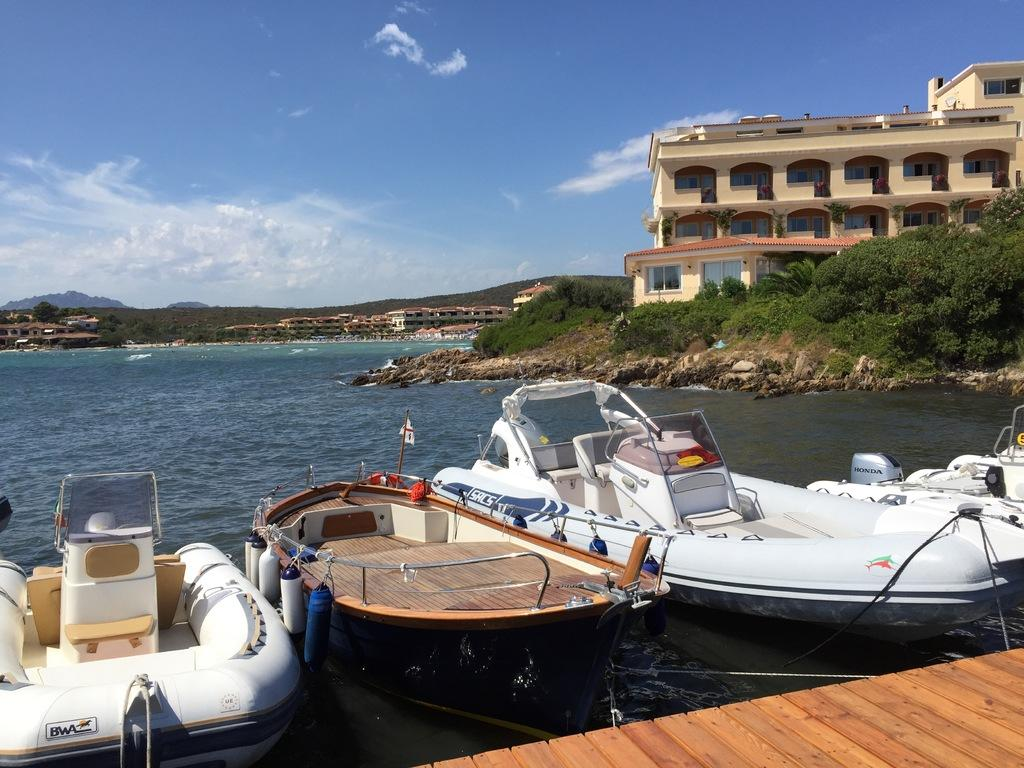What is in the water in the image? There are boats in the water in the image. What can be seen on the right side of the image? There are buildings and trees on the right side of the image. What year is depicted in the image? The image does not depict a specific year; it is a current scene with boats, buildings, and trees. Can you see a man's arm in the image? There is no man or arm present in the image. 